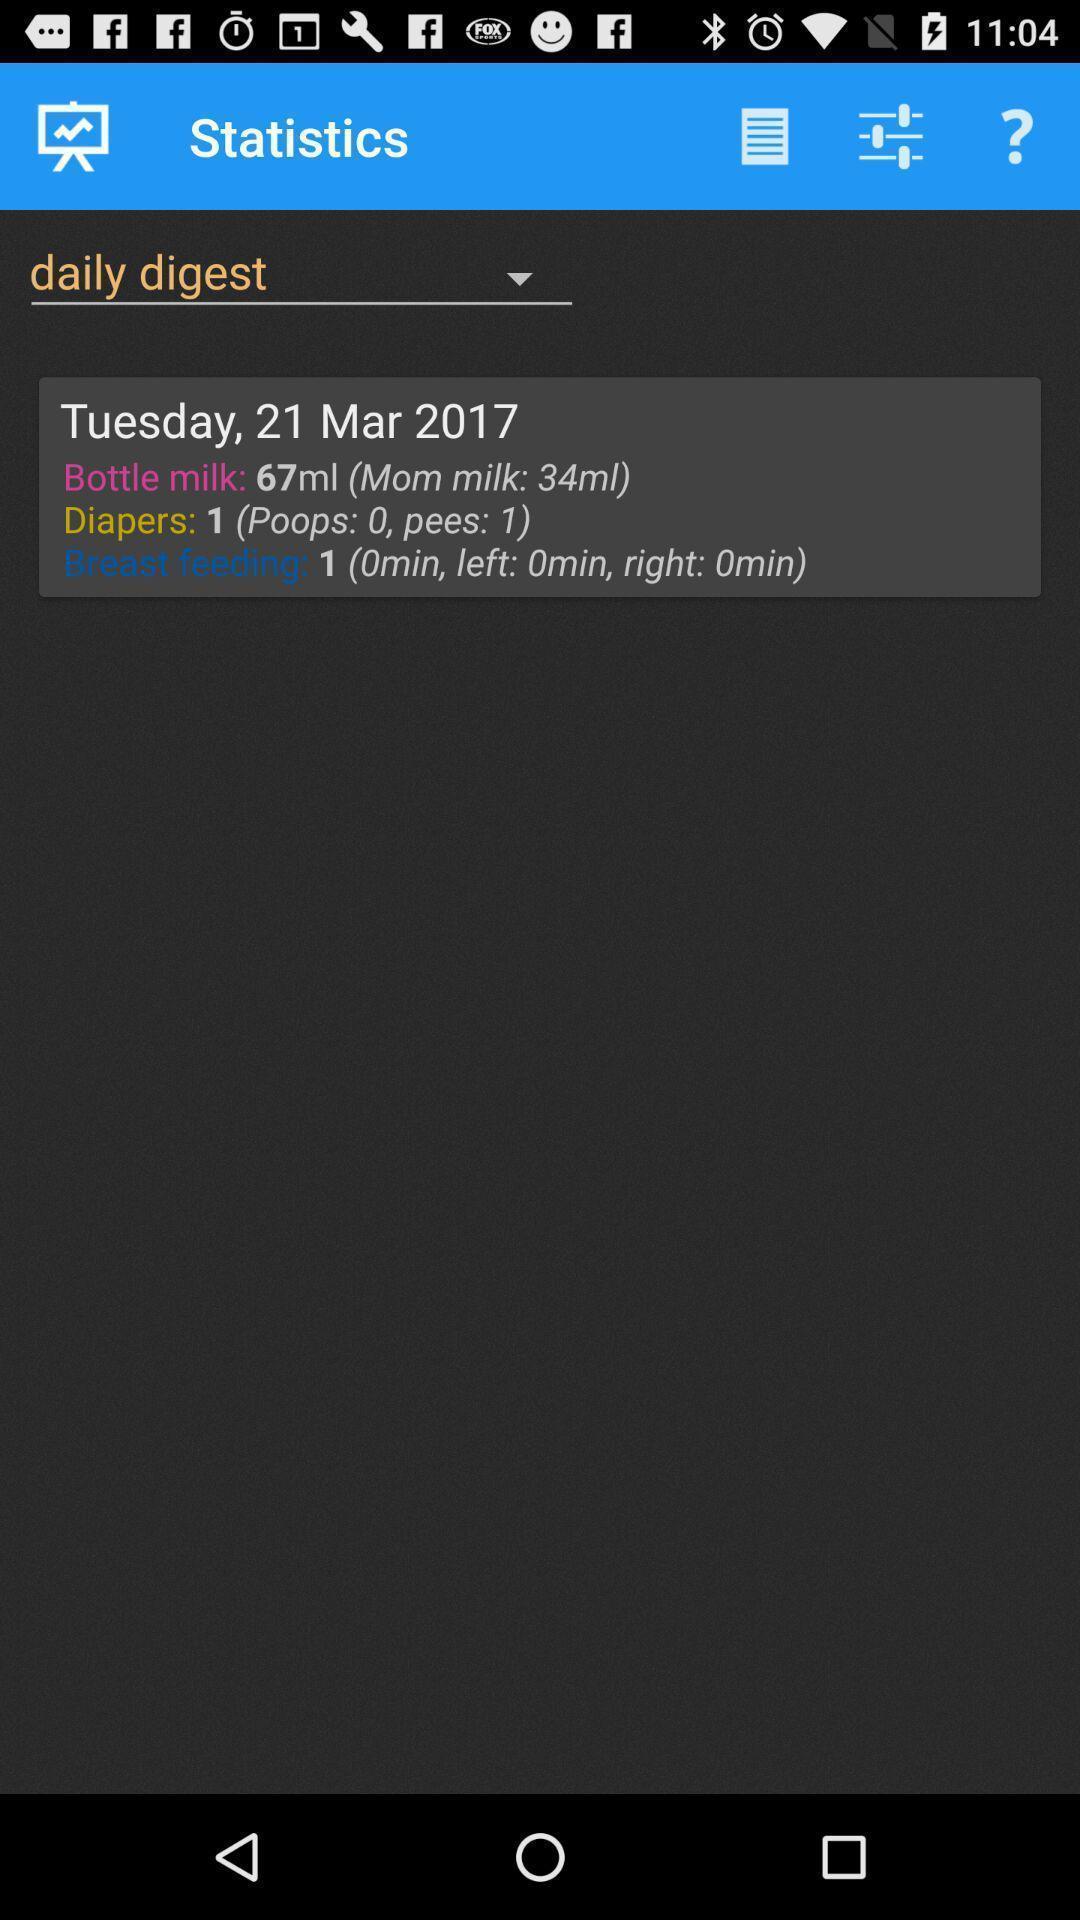Describe the key features of this screenshot. Screen shows statistics details in a health app. 